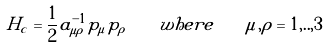<formula> <loc_0><loc_0><loc_500><loc_500>H _ { c } = \frac { 1 } { 2 } a ^ { - 1 } _ { \mu \rho } p _ { \mu } p _ { \rho } \quad w h e r e \quad \mu , \rho = 1 , . . , 3</formula> 